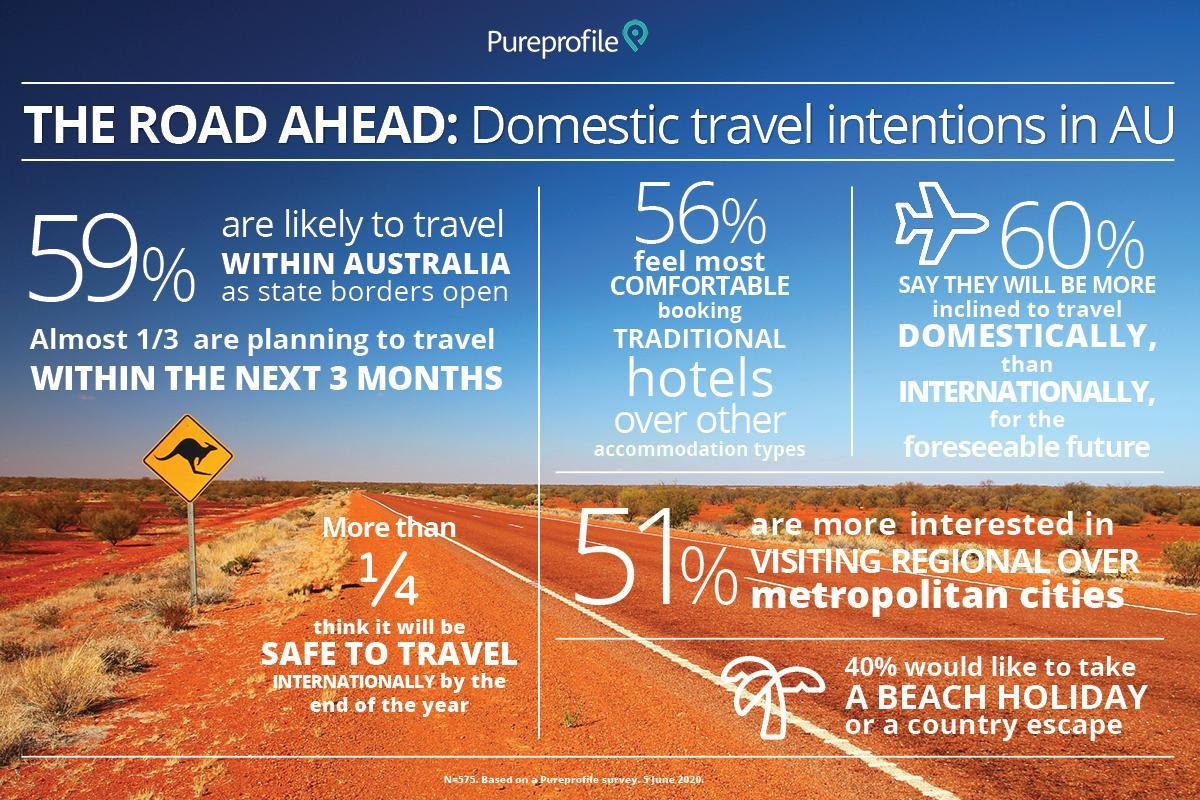What percent think it will be safe to travel internationally by the end of the year?
Answer the question with a short phrase. 25% What percent of people would not be inclined to travel domestically? 40% 